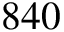Convert formula to latex. <formula><loc_0><loc_0><loc_500><loc_500>8 4 0</formula> 